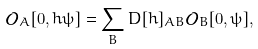Convert formula to latex. <formula><loc_0><loc_0><loc_500><loc_500>\mathcal { O } _ { A } [ 0 , h \psi ] = \sum _ { B } D [ h ] _ { A B } \mathcal { O } _ { B } [ 0 , \psi ] ,</formula> 